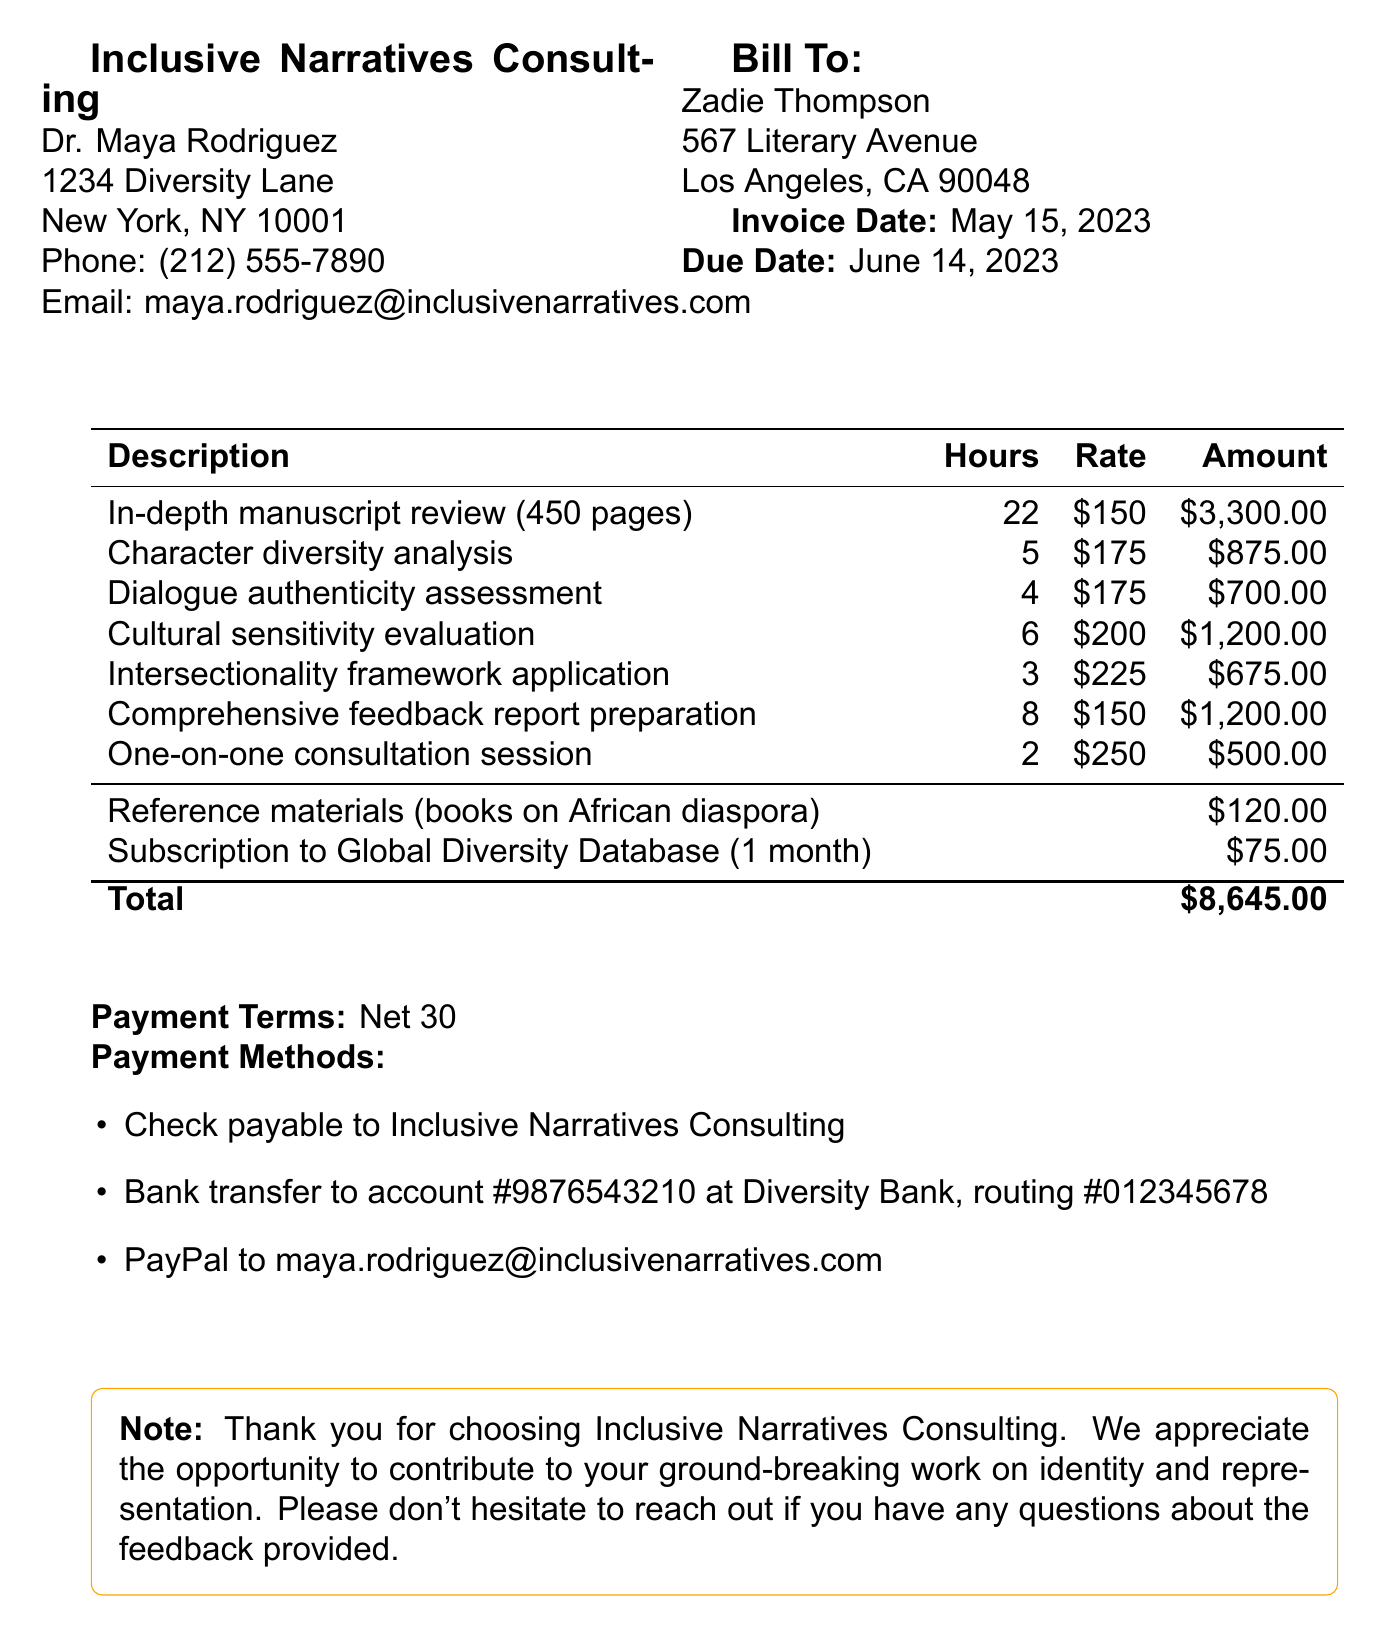What is the total amount of the invoice? The total amount is listed at the bottom of the invoice, which includes all services and additional expenses.
Answer: $8,645.00 Who is the consultant? The consultant's name is provided in the document header, which also includes their contact information.
Answer: Dr. Maya Rodriguez What is the due date of the invoice? The due date is explicitly mentioned in the invoice details section.
Answer: June 14, 2023 How many hours did the consultant spend on the in-depth manuscript review? The number of hours is detailed in the services section for that specific service.
Answer: 22 What is the rate for character diversity analysis? The rate is listed next to the description of the service in the invoice.
Answer: $175 Which payment method requires a bank account number? The payment methods section specifies which payment options are available, including bank transfer.
Answer: Bank transfer What type of evaluation is mentioned regarding cultural sensitivity? The services section describes various evaluations and assessments performed.
Answer: Cultural sensitivity evaluation What is the contact email for the consultant? The consultant's email is provided as part of their contact information in the document.
Answer: maya.rodriguez@inclusivenarratives.com What type of materials were purchased as additional expenses? The additional expenses section lists items that were purchased in relation to the manuscript review.
Answer: Reference materials (books on African diaspora) 